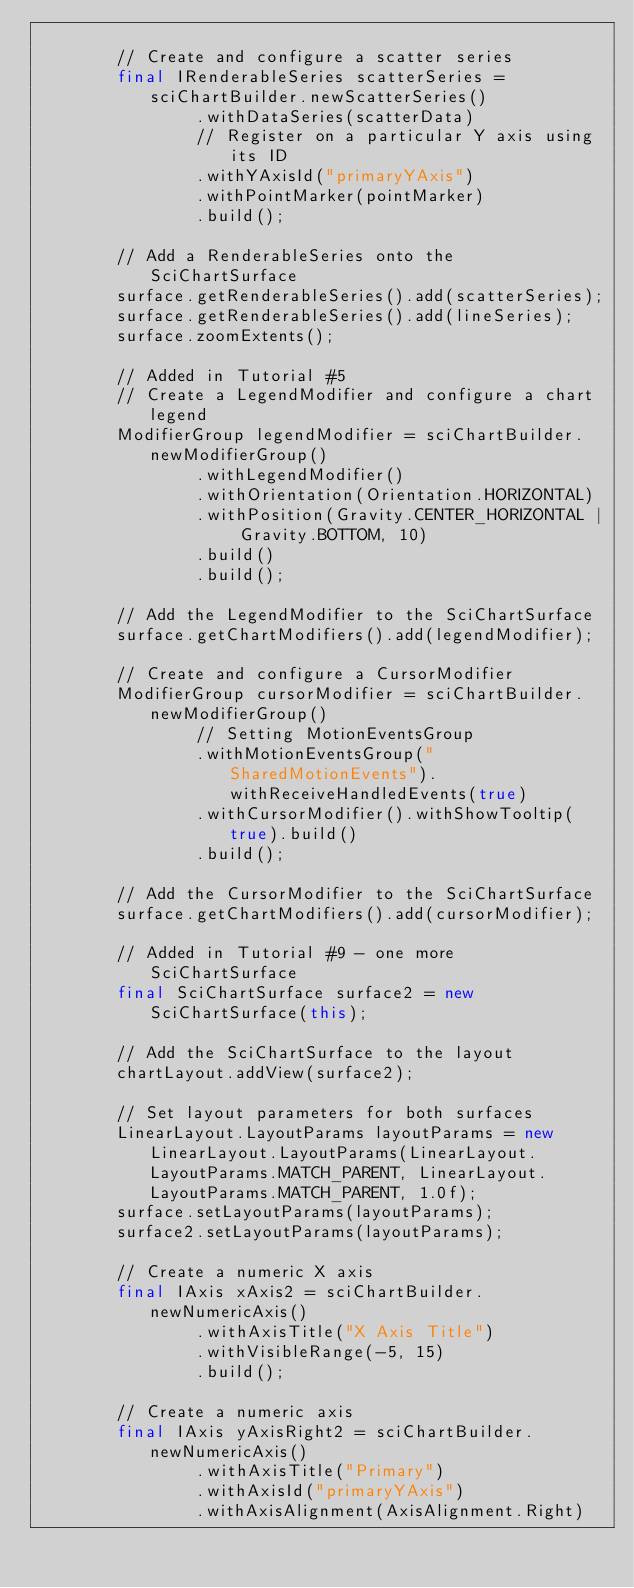<code> <loc_0><loc_0><loc_500><loc_500><_Java_>
        // Create and configure a scatter series
        final IRenderableSeries scatterSeries = sciChartBuilder.newScatterSeries()
                .withDataSeries(scatterData)
                // Register on a particular Y axis using its ID
                .withYAxisId("primaryYAxis")
                .withPointMarker(pointMarker)
                .build();

        // Add a RenderableSeries onto the SciChartSurface
        surface.getRenderableSeries().add(scatterSeries);
        surface.getRenderableSeries().add(lineSeries);
        surface.zoomExtents();

        // Added in Tutorial #5
        // Create a LegendModifier and configure a chart legend
        ModifierGroup legendModifier = sciChartBuilder.newModifierGroup()
                .withLegendModifier()
                .withOrientation(Orientation.HORIZONTAL)
                .withPosition(Gravity.CENTER_HORIZONTAL | Gravity.BOTTOM, 10)
                .build()
                .build();

        // Add the LegendModifier to the SciChartSurface
        surface.getChartModifiers().add(legendModifier);

        // Create and configure a CursorModifier
        ModifierGroup cursorModifier = sciChartBuilder.newModifierGroup()
                // Setting MotionEventsGroup
                .withMotionEventsGroup("SharedMotionEvents").withReceiveHandledEvents(true)
                .withCursorModifier().withShowTooltip(true).build()
                .build();

        // Add the CursorModifier to the SciChartSurface
        surface.getChartModifiers().add(cursorModifier);

        // Added in Tutorial #9 - one more SciChartSurface
        final SciChartSurface surface2 = new SciChartSurface(this);

        // Add the SciChartSurface to the layout
        chartLayout.addView(surface2);

        // Set layout parameters for both surfaces
        LinearLayout.LayoutParams layoutParams = new LinearLayout.LayoutParams(LinearLayout.LayoutParams.MATCH_PARENT, LinearLayout.LayoutParams.MATCH_PARENT, 1.0f);
        surface.setLayoutParams(layoutParams);
        surface2.setLayoutParams(layoutParams);

        // Create a numeric X axis
        final IAxis xAxis2 = sciChartBuilder.newNumericAxis()
                .withAxisTitle("X Axis Title")
                .withVisibleRange(-5, 15)
                .build();

        // Create a numeric axis
        final IAxis yAxisRight2 = sciChartBuilder.newNumericAxis()
                .withAxisTitle("Primary")
                .withAxisId("primaryYAxis")
                .withAxisAlignment(AxisAlignment.Right)</code> 